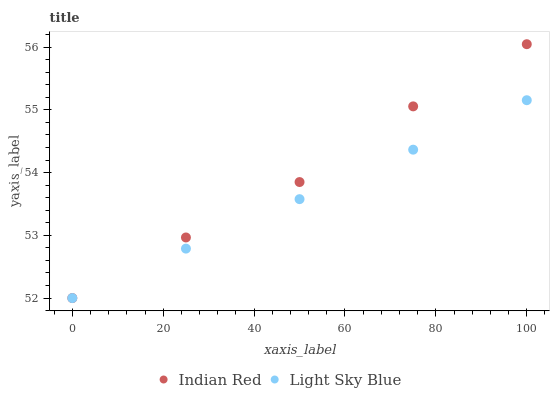Does Light Sky Blue have the minimum area under the curve?
Answer yes or no. Yes. Does Indian Red have the maximum area under the curve?
Answer yes or no. Yes. Does Indian Red have the minimum area under the curve?
Answer yes or no. No. Is Light Sky Blue the smoothest?
Answer yes or no. Yes. Is Indian Red the roughest?
Answer yes or no. Yes. Is Indian Red the smoothest?
Answer yes or no. No. Does Light Sky Blue have the lowest value?
Answer yes or no. Yes. Does Indian Red have the highest value?
Answer yes or no. Yes. Does Light Sky Blue intersect Indian Red?
Answer yes or no. Yes. Is Light Sky Blue less than Indian Red?
Answer yes or no. No. Is Light Sky Blue greater than Indian Red?
Answer yes or no. No. 